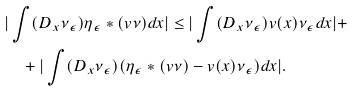<formula> <loc_0><loc_0><loc_500><loc_500>& | \int ( D _ { x } \nu _ { \epsilon } ) \eta _ { \epsilon } * ( v \nu ) d x | \leq | \int ( D _ { x } \nu _ { \epsilon } ) v ( x ) \nu _ { \epsilon } d x | + \\ & \quad + | \int ( D _ { x } \nu _ { \epsilon } ) ( \eta _ { \epsilon } * ( v \nu ) - v ( x ) \nu _ { \epsilon } ) d x | .</formula> 